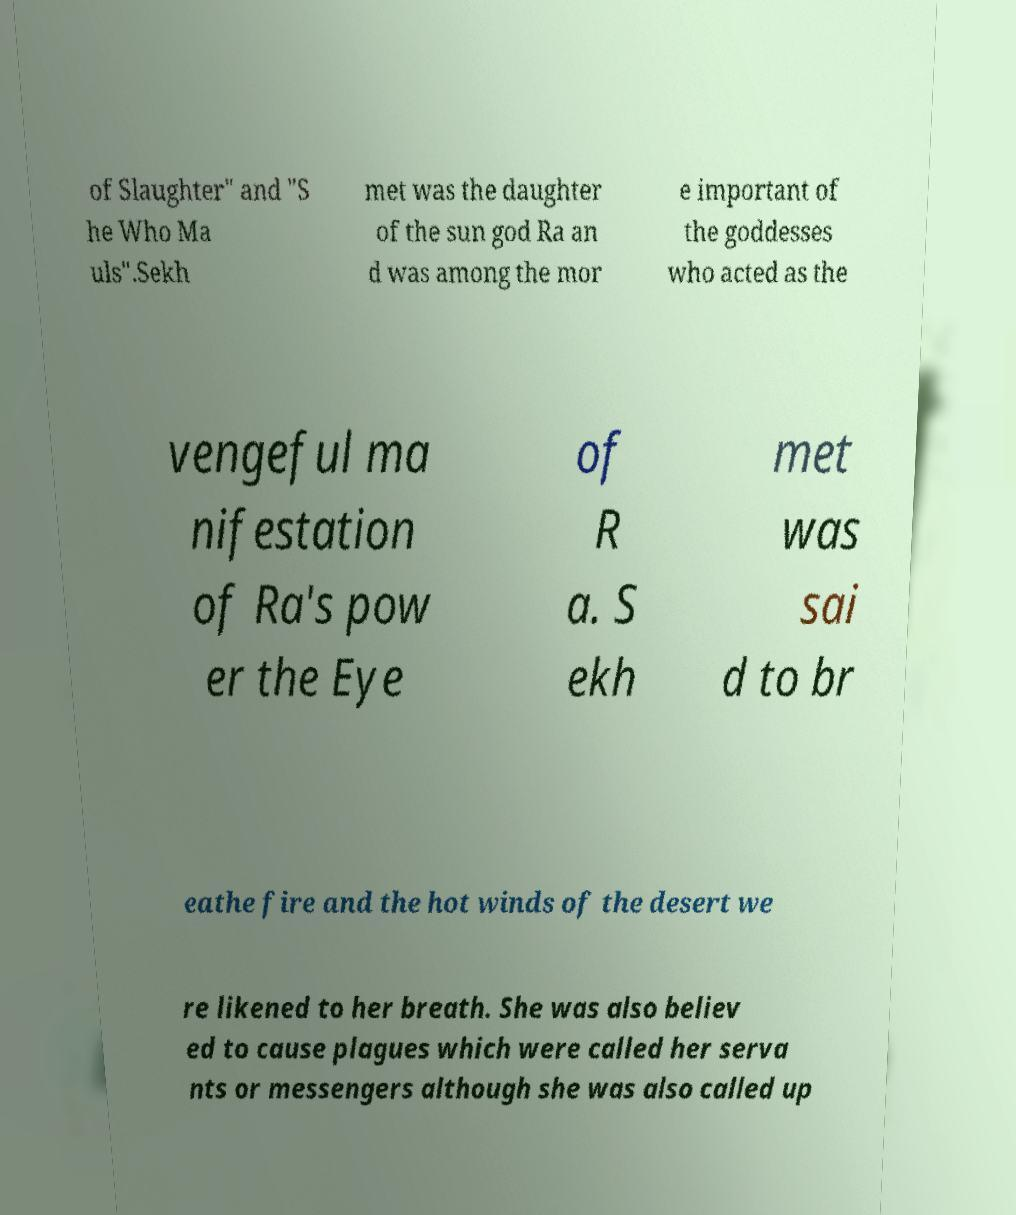Could you extract and type out the text from this image? of Slaughter" and "S he Who Ma uls".Sekh met was the daughter of the sun god Ra an d was among the mor e important of the goddesses who acted as the vengeful ma nifestation of Ra's pow er the Eye of R a. S ekh met was sai d to br eathe fire and the hot winds of the desert we re likened to her breath. She was also believ ed to cause plagues which were called her serva nts or messengers although she was also called up 